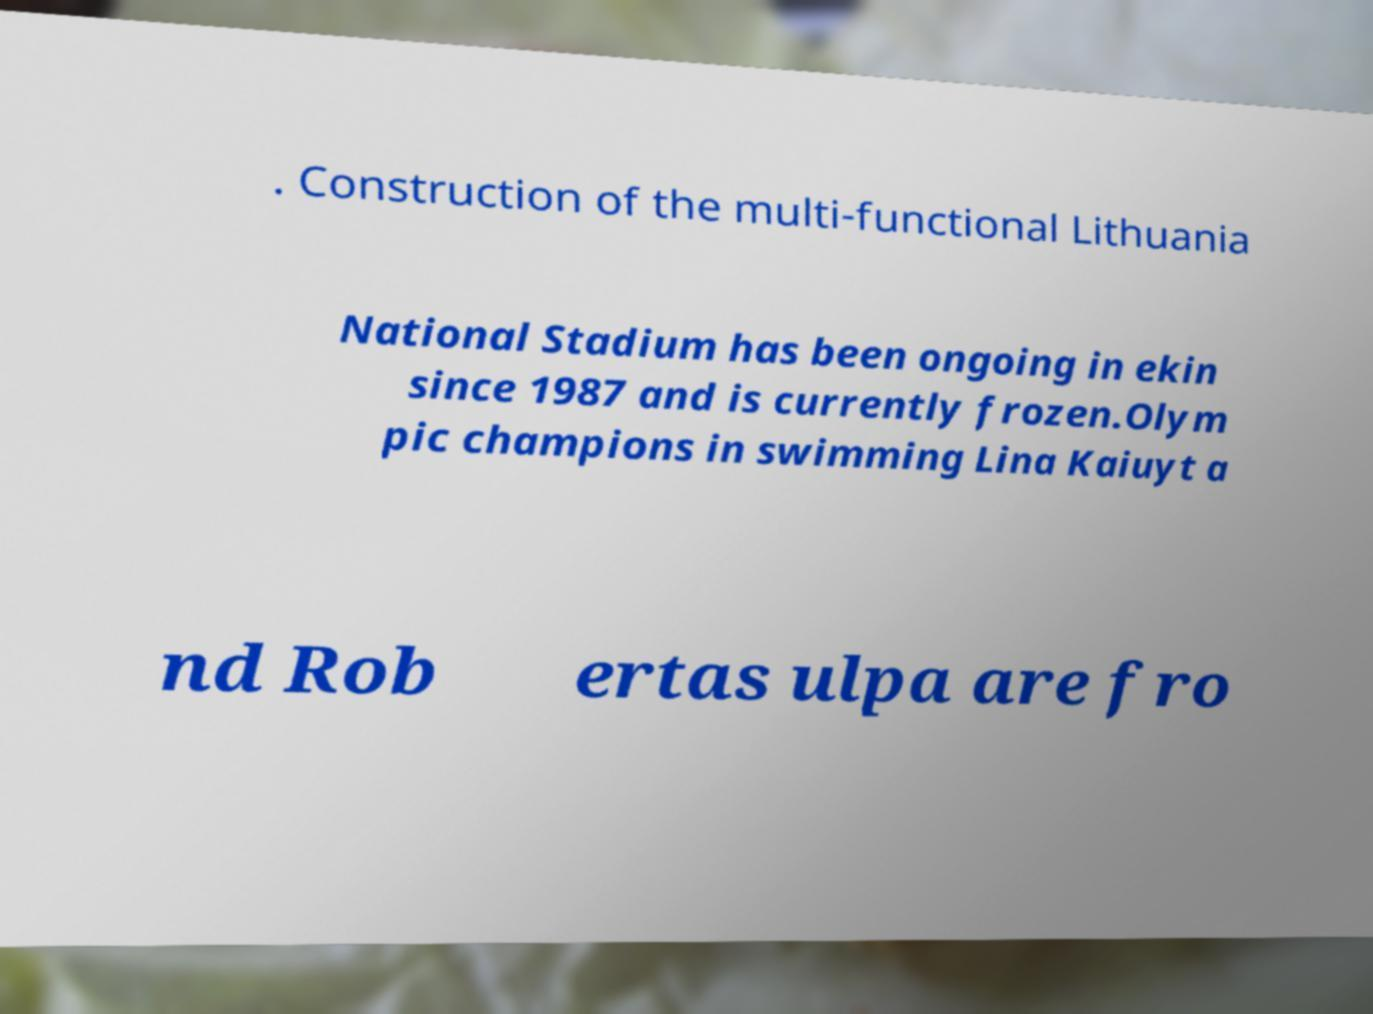There's text embedded in this image that I need extracted. Can you transcribe it verbatim? . Construction of the multi-functional Lithuania National Stadium has been ongoing in ekin since 1987 and is currently frozen.Olym pic champions in swimming Lina Kaiuyt a nd Rob ertas ulpa are fro 